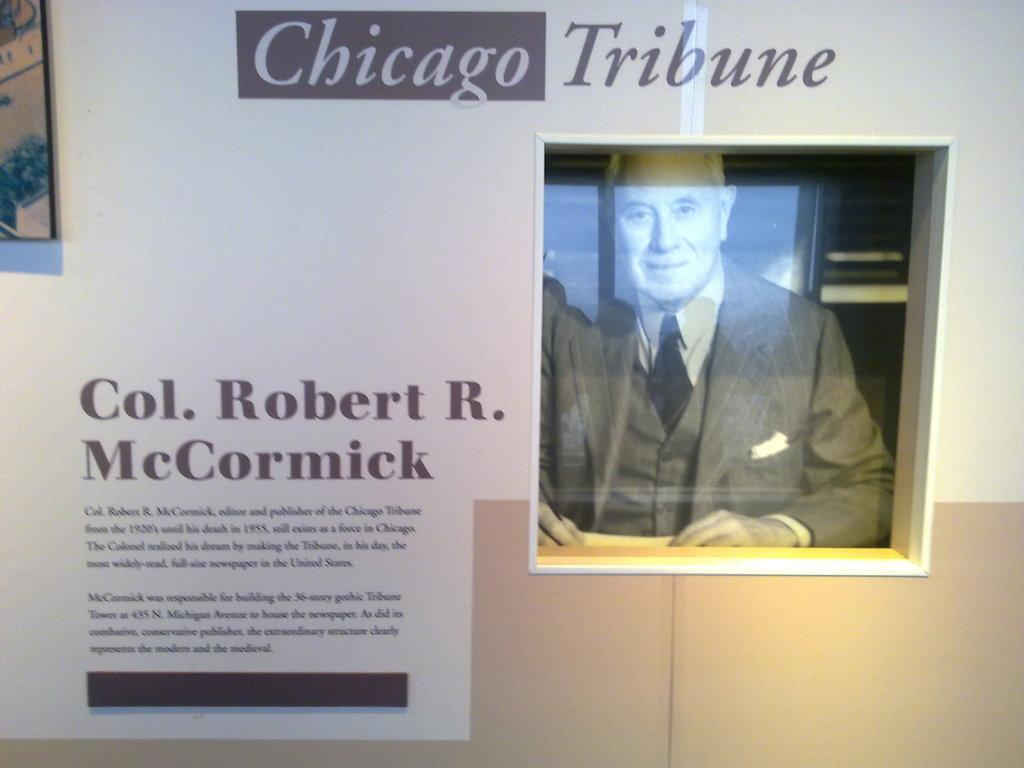What is the main object in the center of the image? There is a photo frame in the center of the image. What is displayed inside the photo frame? The photo frame contains a picture of a person. What can be seen on the wall in the image? There are posters on the wall. What is written or depicted on the posters? The posters have text on them. How many feet are visible in the image? There are no feet visible in the image. Is there a park shown in the image? There is no park present in the image. 